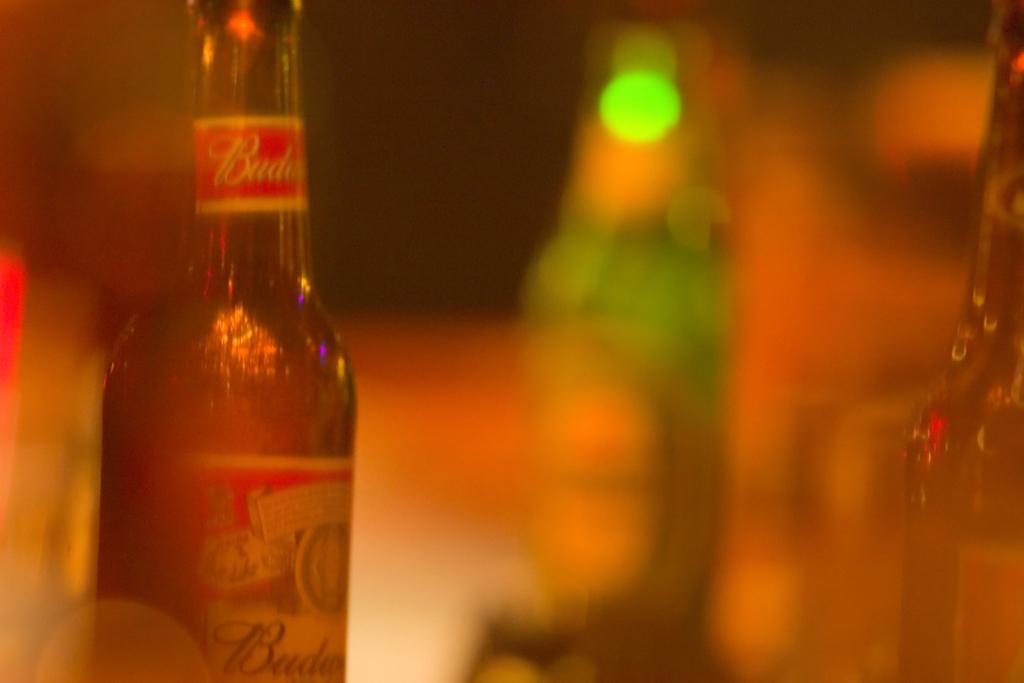What type of objects are present in large quantities in the image? There are many glass bottles in the image. What hobbies do the toads in the image enjoy? There are no toads present in the image, so it is not possible to determine their hobbies. 